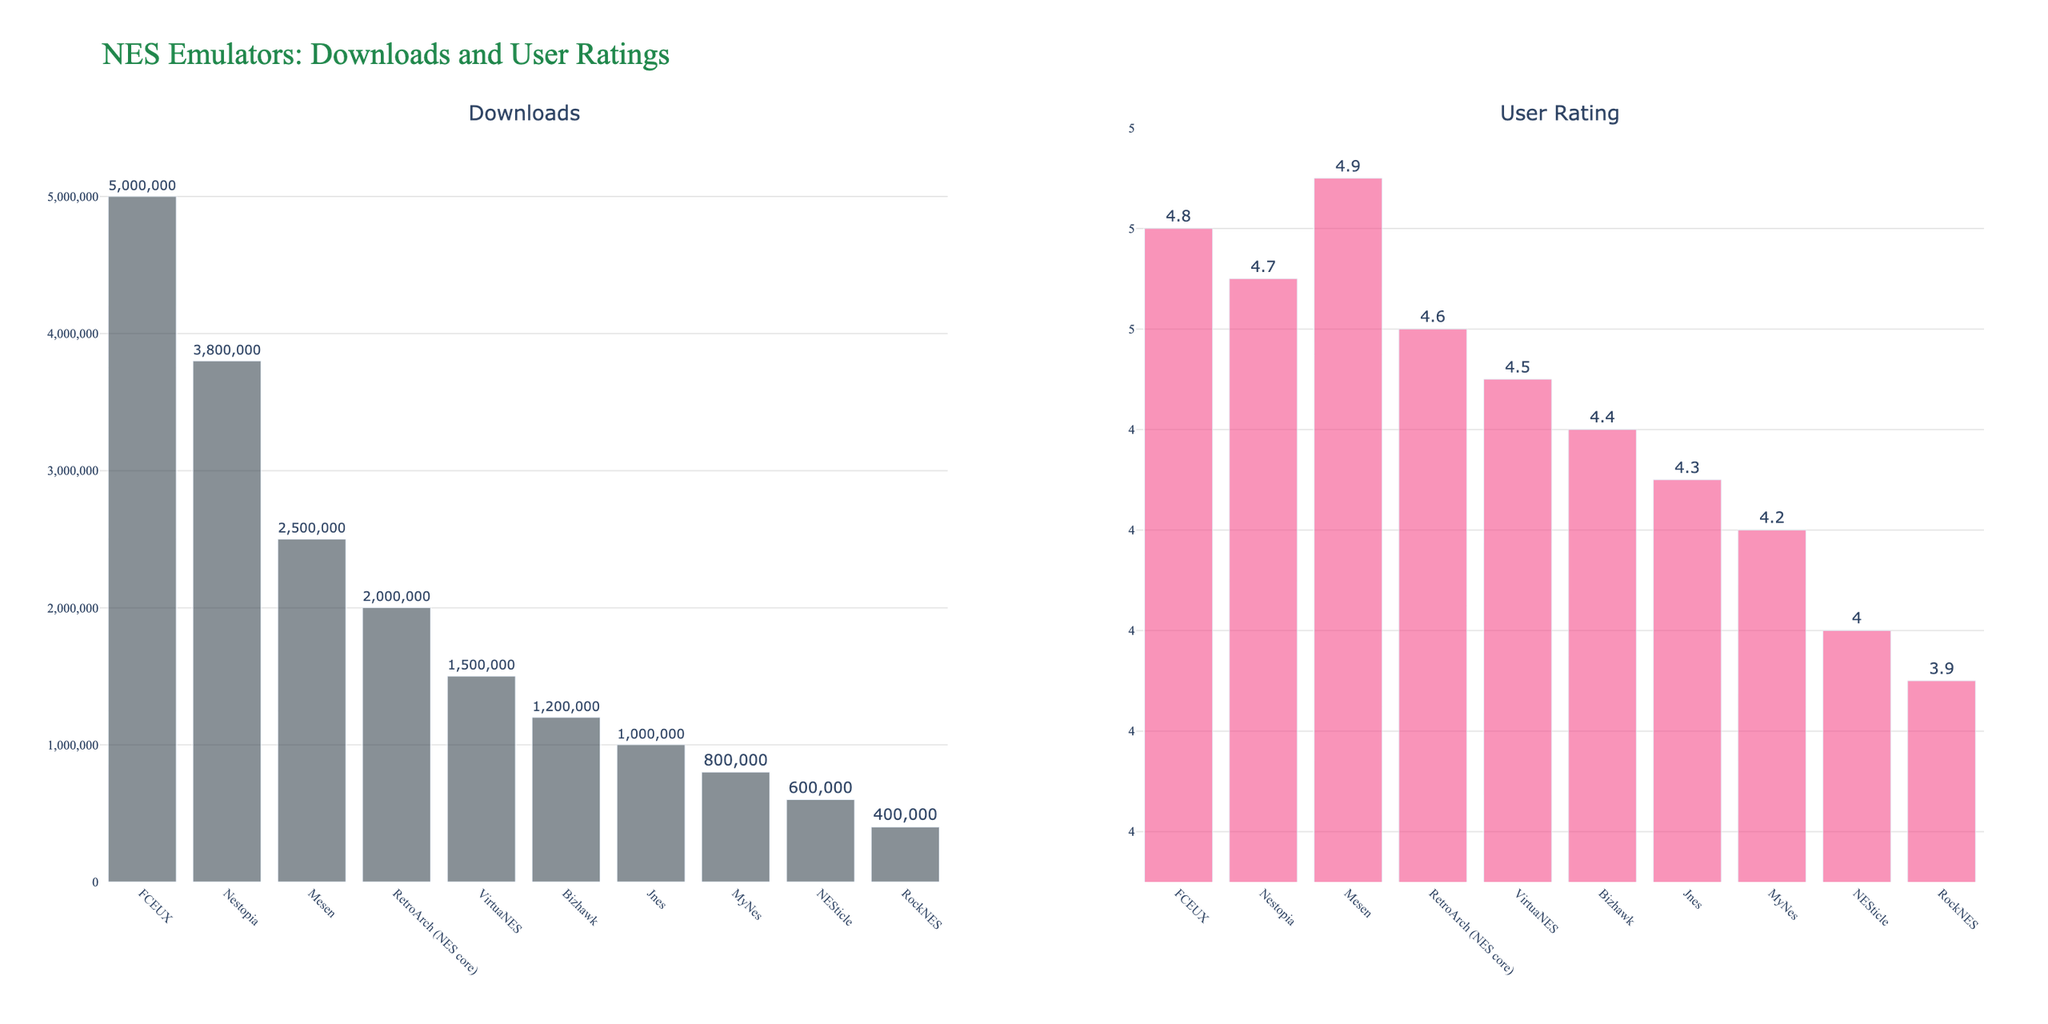Which emulator has the highest user rating? By examining the user ratings bar chart, we can see that the emulator Mesen has the highest user rating among the listed emulators. This is represented visually by the tallest bar in the User Ratings chart.
Answer: Mesen Which emulator has the most downloads? By examining the downloads bar chart, it is clear that FCEUX has the most downloads. This can be identified by the height of the bar representing FCEUX, which is the tallest in the Downloads chart.
Answer: FCEUX How many total downloads do the top three emulators have combined? To find the total downloads of the top three emulators, we sum the downloads of FCEUX, Nestopia, and Mesen. These values are 5,000,000 for FCEUX, 3,800,000 for Nestopia, and 2,500,000 for Mesen. Adding them together gives 5,000,000 + 3,800,000 + 2,500,000 = 11,300,000.
Answer: 11,300,000 Which emulator has the lowest user rating and what is that rating? The lowest user rating can be found by identifying the shortest bar in the User Ratings chart. The shortest bar belongs to RockNES, with a user rating of 3.9.
Answer: RockNES, 3.9 Which emulator has fewer downloads, Bizhawk or MyNes? By comparing the height of the bars in the Downloads chart, it is clear that MyNes has fewer downloads than Bizhawk. The download count for Bizhawk is 1,200,000, while MyNes has 800,000 downloads.
Answer: MyNes What is the difference in user ratings between FCEUX and RockNES? To find the difference, we subtract the user rating of RockNES from that of FCEUX. The ratings are 4.8 for FCEUX and 3.9 for RockNES. So, the difference is 4.8 - 3.9 = 0.9.
Answer: 0.9 Are there any emulators with the same download count? By examining the Downloads chart, we can see that all emulators have different download counts. Hence, no two emulators share the same number of downloads.
Answer: No Which emulator ranks third in terms of user rating? The third highest user rating on the chart belongs to Nestopia, with a rating of 4.7. This can be determined by ordering the bars in the User Ratings chart. The first is Mesen (4.9), second is FCEUX (4.8), and third is Nestopia (4.7).
Answer: Nestopia 